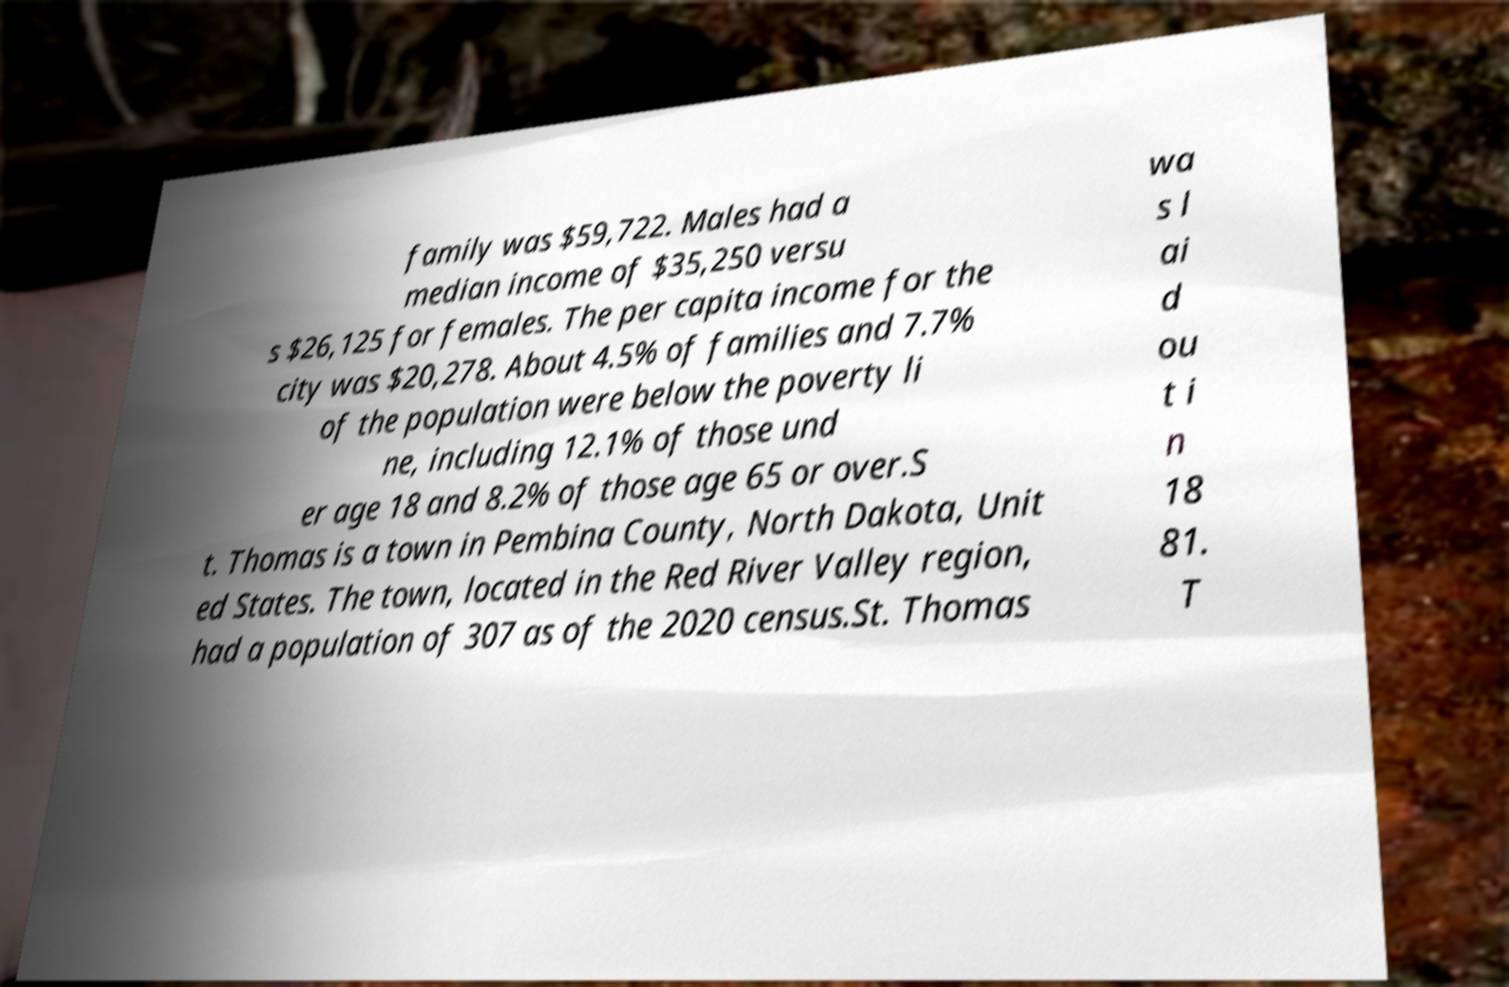Could you assist in decoding the text presented in this image and type it out clearly? family was $59,722. Males had a median income of $35,250 versu s $26,125 for females. The per capita income for the city was $20,278. About 4.5% of families and 7.7% of the population were below the poverty li ne, including 12.1% of those und er age 18 and 8.2% of those age 65 or over.S t. Thomas is a town in Pembina County, North Dakota, Unit ed States. The town, located in the Red River Valley region, had a population of 307 as of the 2020 census.St. Thomas wa s l ai d ou t i n 18 81. T 